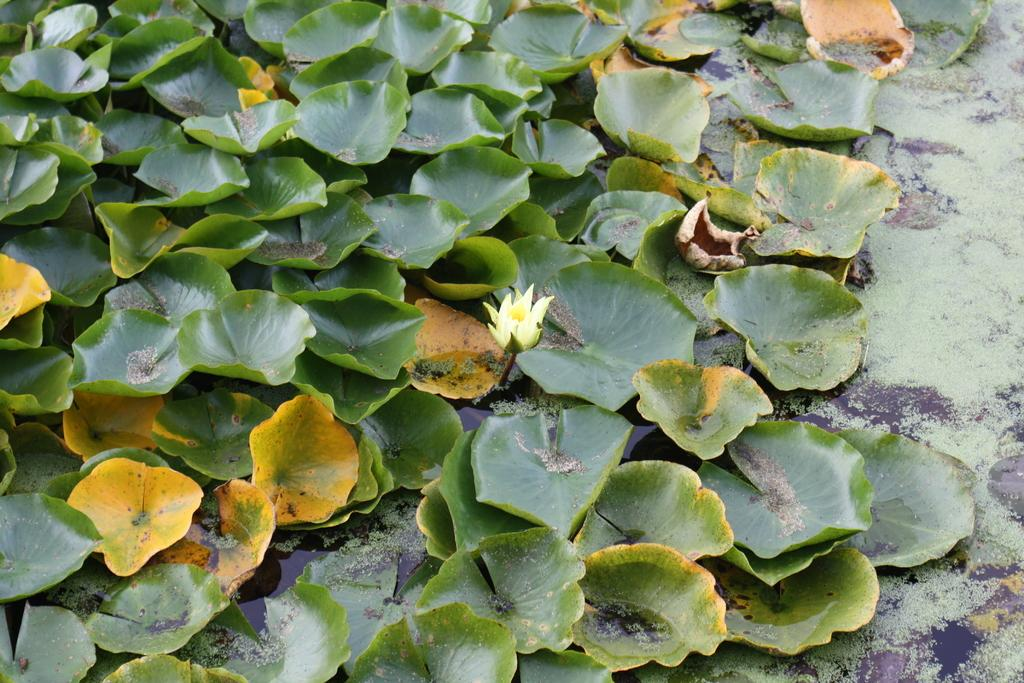What is present in the image? There is a flower and plants floating on the water in the image. Can you describe the flower in the image? Unfortunately, the facts provided do not give enough detail to describe the flower. How are the plants situated in the image? The plants are floating on the water in the image. What type of hammer is being used to hit the whip in the image? There is no hammer or whip present in the image; it features a flower and plants floating on the water. 